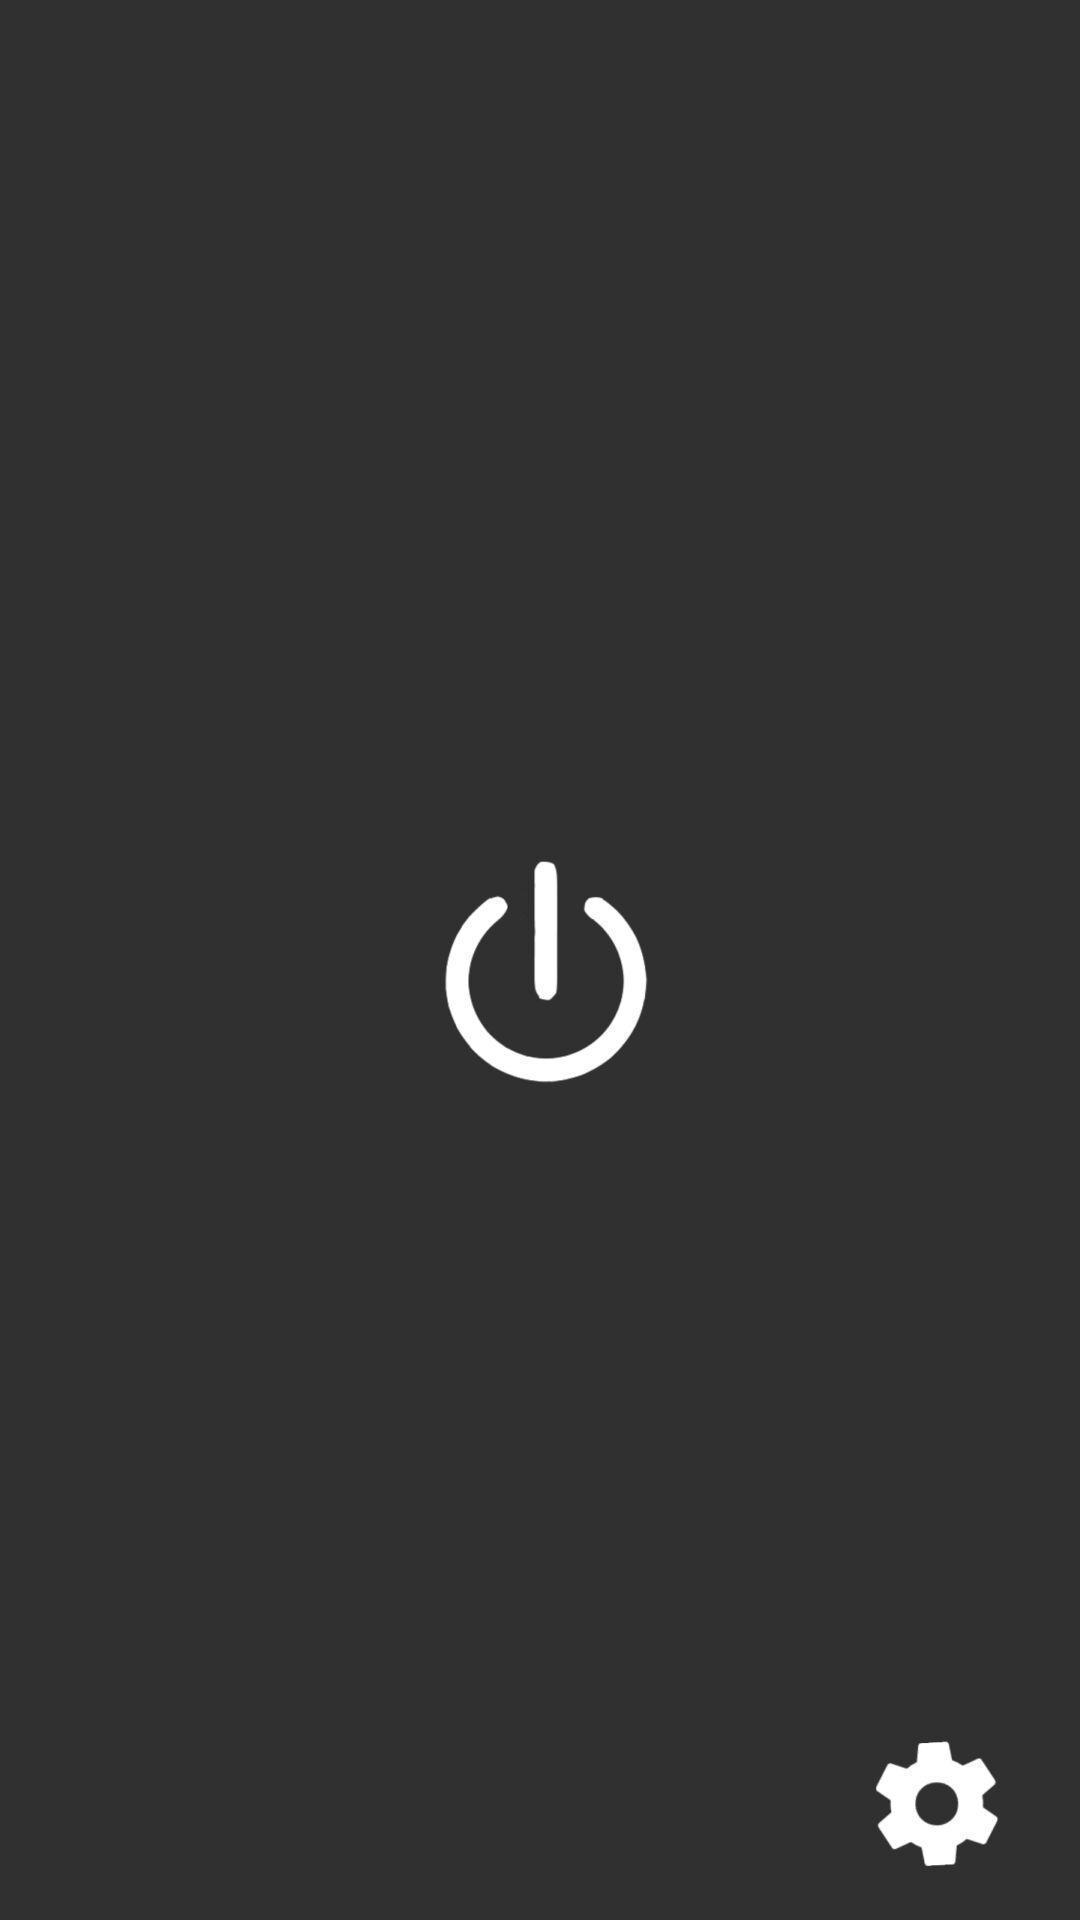Provide a description of this screenshot. Page of the power mode. 